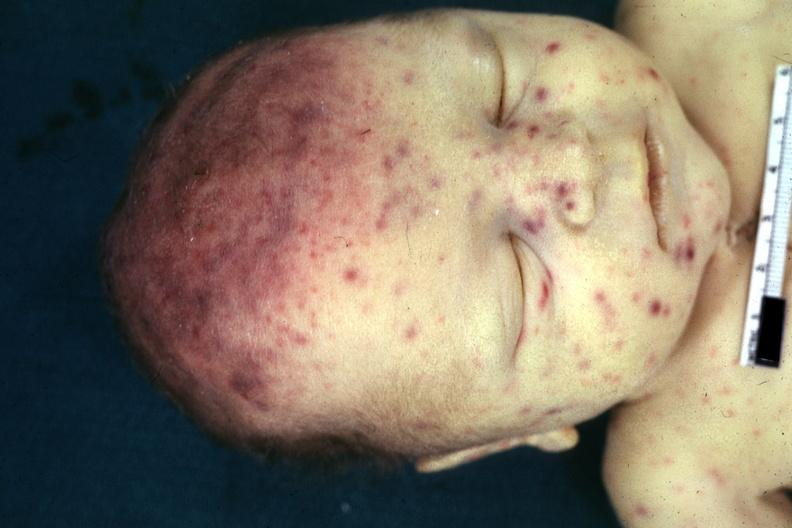what does this image show?
Answer the question using a single word or phrase. Face jaundice and multiple petechial and purpuric hemorrhages 